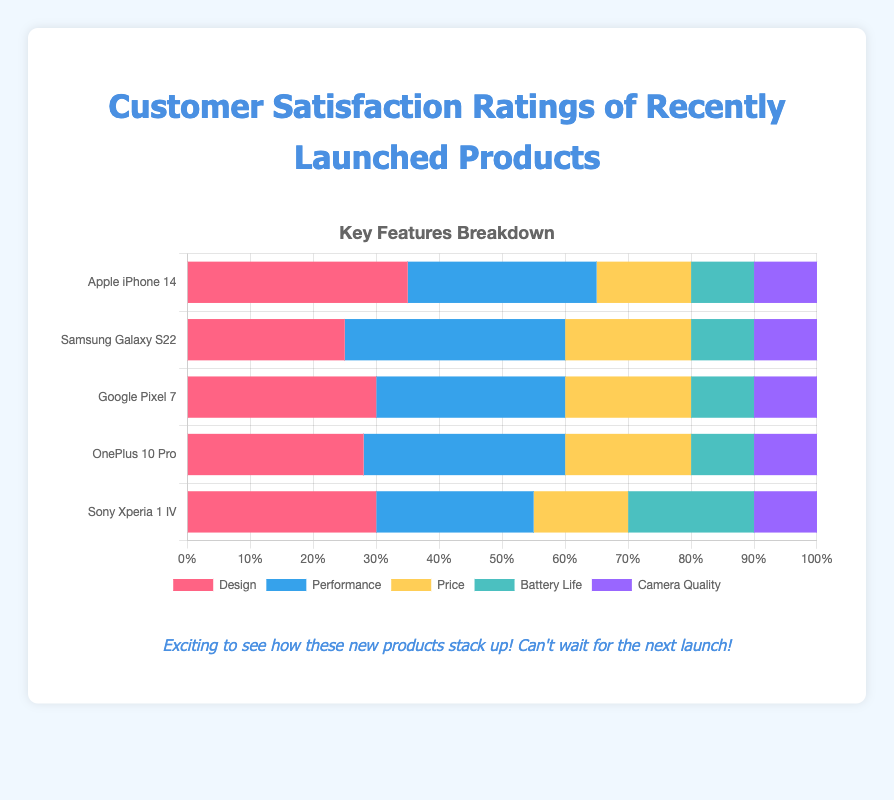Which product has the highest customer satisfaction rating for "Performance"? By examining the "Performance" section of each bar in the chart, Samsung Galaxy S22 clearly has the highest individual satisfaction rating for "Performance".
Answer: Samsung Galaxy S22 Which two products have equal ratings for "Camera Quality"? By looking at the "Camera Quality" segments of each bar, Apple iPhone 14, Samsung Galaxy S22, Google Pixel 7, and OnePlus 10 Pro all have the same rating for "Camera Quality" at 0.10.
Answer: Apple iPhone 14, Samsung Galaxy S22, Google Pixel 7, OnePlus 10 Pro What is the combined rating for "Design" and "Price" for OnePlus 10 Pro? The "Design" rating for OnePlus 10 Pro is 0.28, and the "Price" rating is 0.20. Adding them together gives 0.28 + 0.20 = 0.48.
Answer: 0.48 Which product has the highest combined satisfaction rating for "Battery Life" and "Price"? Adding the "Battery Life" and "Price" ratings for each product: Apple iPhone 14 (0.10 + 0.15 = 0.25), Samsung Galaxy S22 (0.10 + 0.20 = 0.30), Google Pixel 7 (0.10 + 0.20 = 0.30), OnePlus 10 Pro (0.10 + 0.20 = 0.30), Sony Xperia 1 IV (0.20 + 0.15 = 0.35). So, Sony Xperia 1 IV has the highest combined rating of 0.35.
Answer: Sony Xperia 1 IV Which product has the lowest satisfaction rating for "Design"? By comparing the "Design" segments of the bars, Samsung Galaxy S22 has the lowest rating at 0.25.
Answer: Samsung Galaxy S22 What is the average satisfaction rating for "Performance" across all products? Summing the "Performance" ratings: 0.30 (iPhone 14) + 0.35 (Galaxy S22) + 0.30 (Pixel 7) + 0.32 (OnePlus 10 Pro) + 0.25 (Xperia 1 IV) = 1.52. Dividing by 5 products, the average is 1.52 / 5 = 0.304.
Answer: 0.304 Which product has the smallest gap between "Design" and "Performance" ratings? Calculating the absolute difference between "Design" and "Performance": iPhone 14 (0.35 - 0.30 = 0.05), Galaxy S22 (0.35 - 0.25 = 0.10), Pixel 7 (0.30 - 0.30 = 0.00), OnePlus 10 Pro (0.32 - 0.28 = 0.04), Xperia 1 IV (0.30 - 0.25 = 0.05). The smallest gap is for Google Pixel 7 at 0.00.
Answer: Google Pixel 7 Which product has the highest satisfaction rating for "Battery Life"? By examining the "Battery Life" section of each bar, Sony Xperia 1 IV has the highest satisfaction rating at 0.20.
Answer: Sony Xperia 1 IV What is the total satisfaction rating for Apple iPhone 14 across all features? Summing all feature ratings for Apple iPhone 14: 0.35 (Design) + 0.30 (Performance) + 0.15 (Price) + 0.10 (Battery Life) + 0.10 (Camera Quality) = 1.00.
Answer: 1.00 